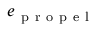Convert formula to latex. <formula><loc_0><loc_0><loc_500><loc_500>e _ { p r o p e l }</formula> 